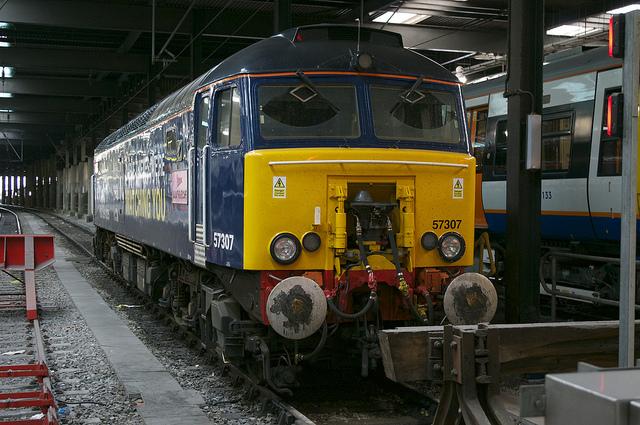Is the train causing a lot of smoke?
Short answer required. No. What color are the wheels of this train?
Concise answer only. Black. Who drives this vehicle?
Keep it brief. Engineer. What kind of vehicle is shown?
Short answer required. Train. Is there more than one train?
Answer briefly. Yes. 